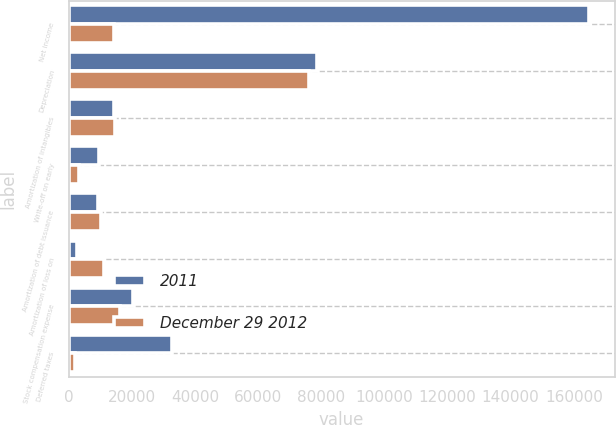Convert chart to OTSL. <chart><loc_0><loc_0><loc_500><loc_500><stacked_bar_chart><ecel><fcel>Net income<fcel>Depreciation<fcel>Amortization of intangibles<fcel>Write-off on early<fcel>Amortization of debt issuance<fcel>Amortization of loss on<fcel>Stock compensation expense<fcel>Deferred taxes<nl><fcel>2011<fcel>164681<fcel>78784<fcel>14252<fcel>9559<fcel>9168<fcel>2560<fcel>20496<fcel>32583<nl><fcel>December 29 2012<fcel>14252<fcel>76174<fcel>14551<fcel>3297<fcel>10367<fcel>11292<fcel>16173<fcel>1948<nl></chart> 